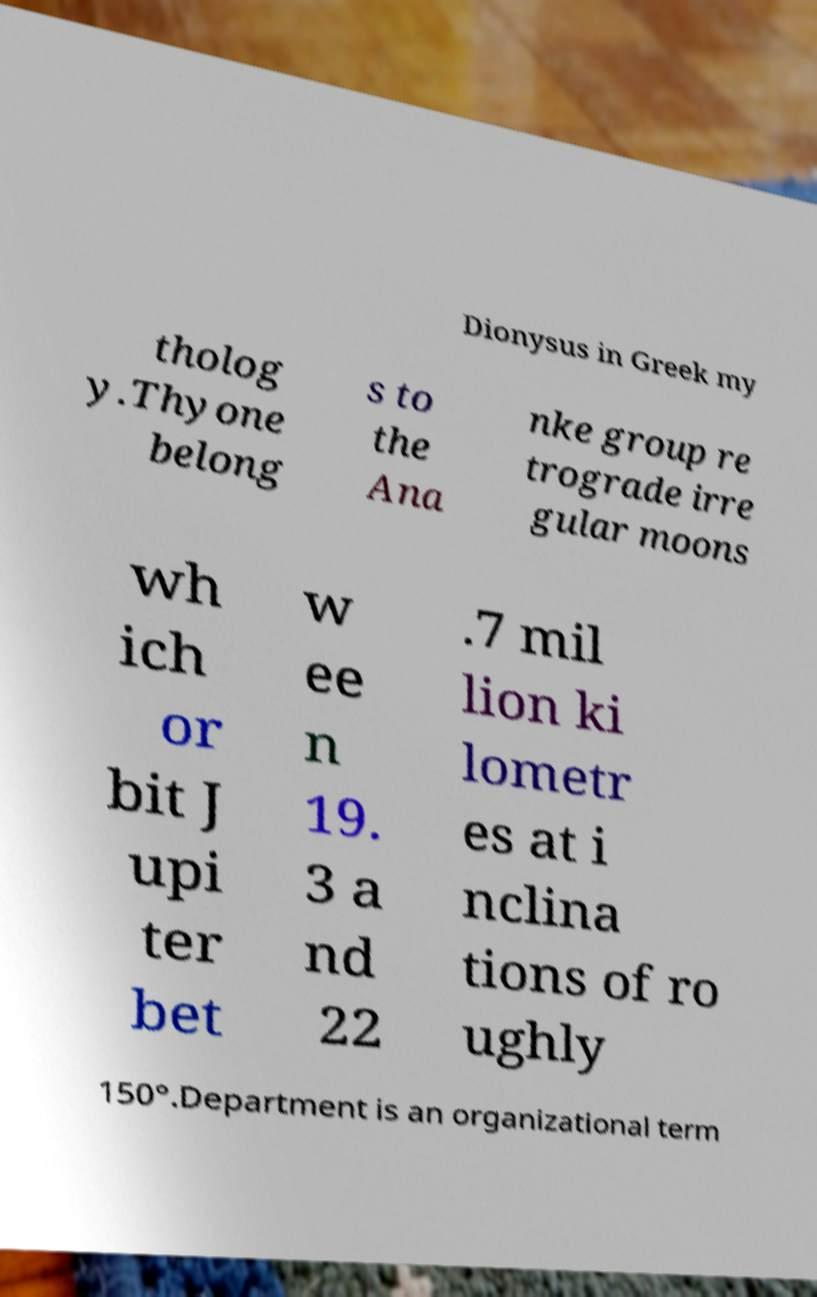There's text embedded in this image that I need extracted. Can you transcribe it verbatim? Dionysus in Greek my tholog y.Thyone belong s to the Ana nke group re trograde irre gular moons wh ich or bit J upi ter bet w ee n 19. 3 a nd 22 .7 mil lion ki lometr es at i nclina tions of ro ughly 150°.Department is an organizational term 